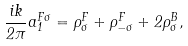Convert formula to latex. <formula><loc_0><loc_0><loc_500><loc_500>\frac { i k } { 2 \pi } a _ { 1 } ^ { F \sigma } = \rho _ { \sigma } ^ { F } + \rho _ { - \sigma } ^ { F } + 2 \rho _ { \sigma } ^ { B } ,</formula> 